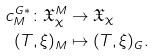Convert formula to latex. <formula><loc_0><loc_0><loc_500><loc_500>c ^ { G * } _ { M } \colon \mathfrak X ^ { M } _ { \chi } & \rightarrow \mathfrak X _ { \chi } \\ ( T , \xi ) _ { M } & \mapsto ( T , \xi ) _ { G } .</formula> 